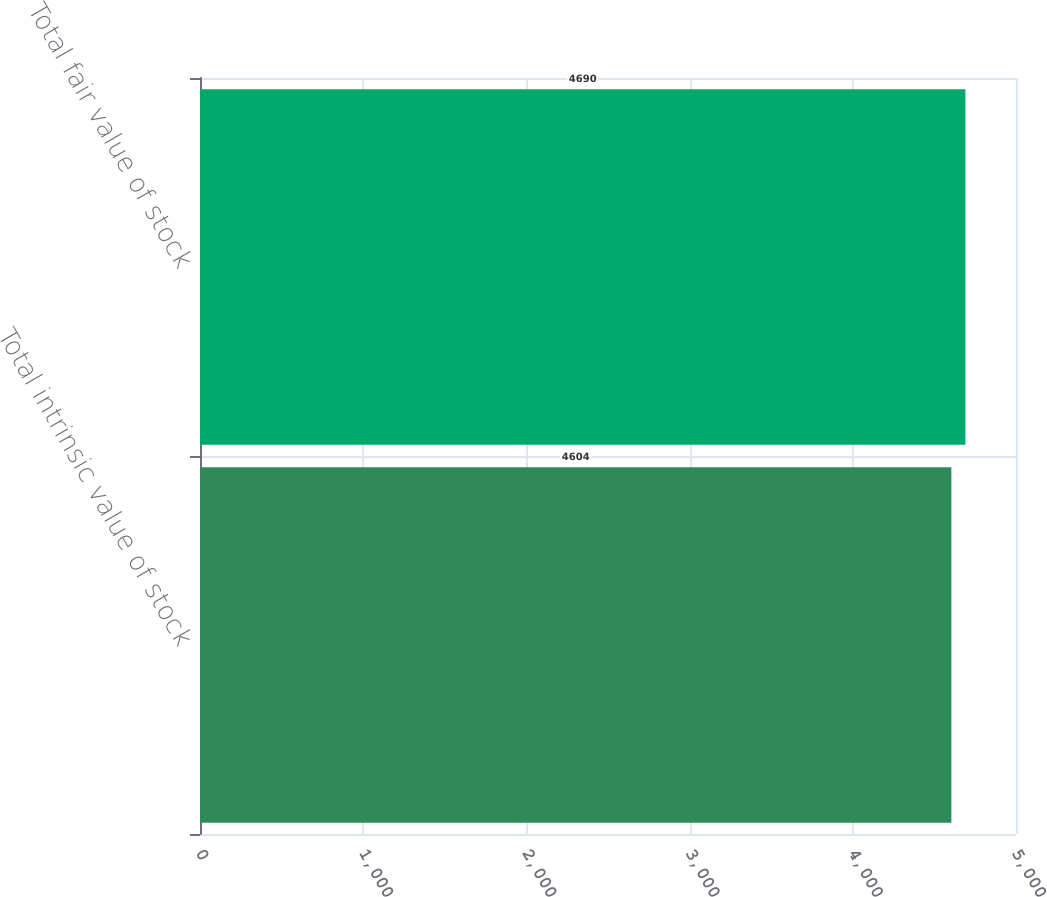Convert chart to OTSL. <chart><loc_0><loc_0><loc_500><loc_500><bar_chart><fcel>Total intrinsic value of stock<fcel>Total fair value of stock<nl><fcel>4604<fcel>4690<nl></chart> 